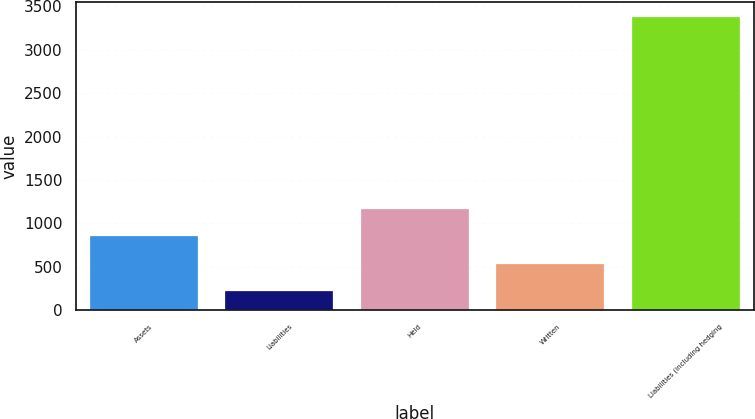Convert chart to OTSL. <chart><loc_0><loc_0><loc_500><loc_500><bar_chart><fcel>Assets<fcel>Liabilities<fcel>Held<fcel>Written<fcel>Liabilities (including hedging<nl><fcel>847.4<fcel>215<fcel>1163.6<fcel>531.2<fcel>3377<nl></chart> 